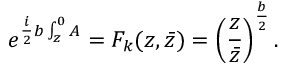Convert formula to latex. <formula><loc_0><loc_0><loc_500><loc_500>e ^ { { \frac { i } { 2 } } b \int _ { z } ^ { 0 } A } = F _ { k } ( z , \bar { z } ) = \left ( { \frac { z } { \bar { z } } } \right ) ^ { \frac { b } { 2 } } .</formula> 